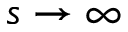<formula> <loc_0><loc_0><loc_500><loc_500>s \rightarrow \infty</formula> 